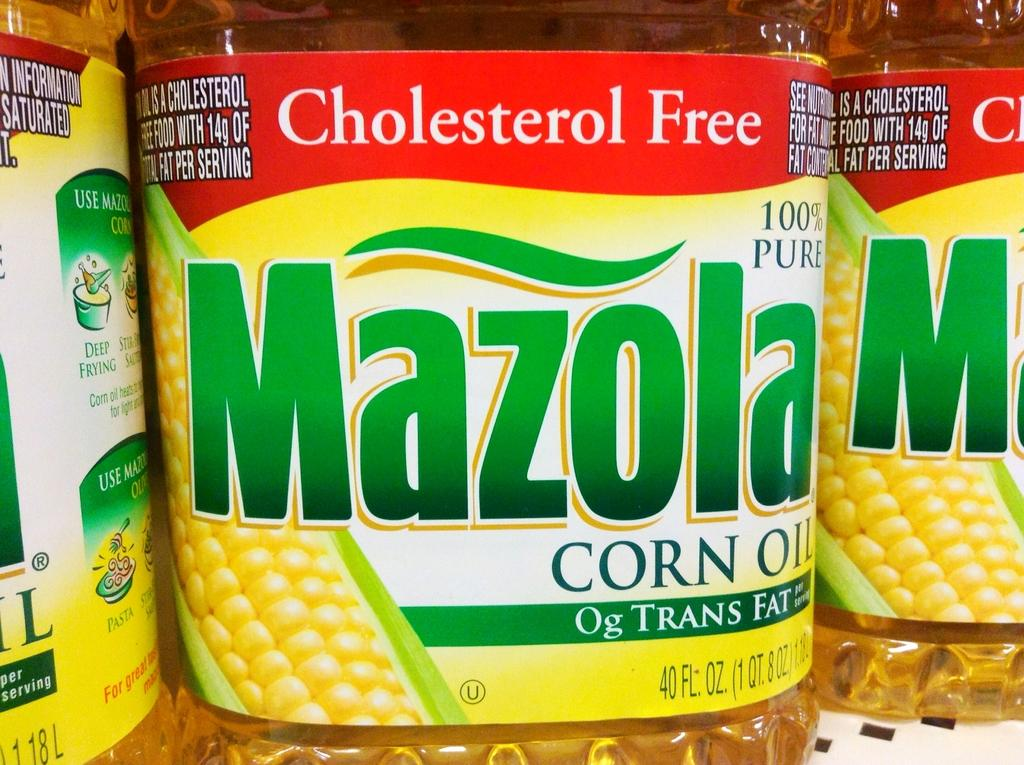What type of containers are present in the image? There are oil bottles in the image. What can be found on the oil containers? The oil containers have labels. What information is included on the labels? The labels contain text. What type of image is printed on the labels? The labels have a corny photo printed on them. How many oranges are being exchanged between the people in the image? There are no people or oranges present in the image; it features oil bottles with labeled containers. 